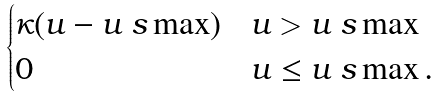Convert formula to latex. <formula><loc_0><loc_0><loc_500><loc_500>\begin{cases} \kappa ( u - u _ { \ } s \max ) & u > u _ { \ } s \max \\ 0 & u \leq u _ { \ } s \max . \end{cases}</formula> 